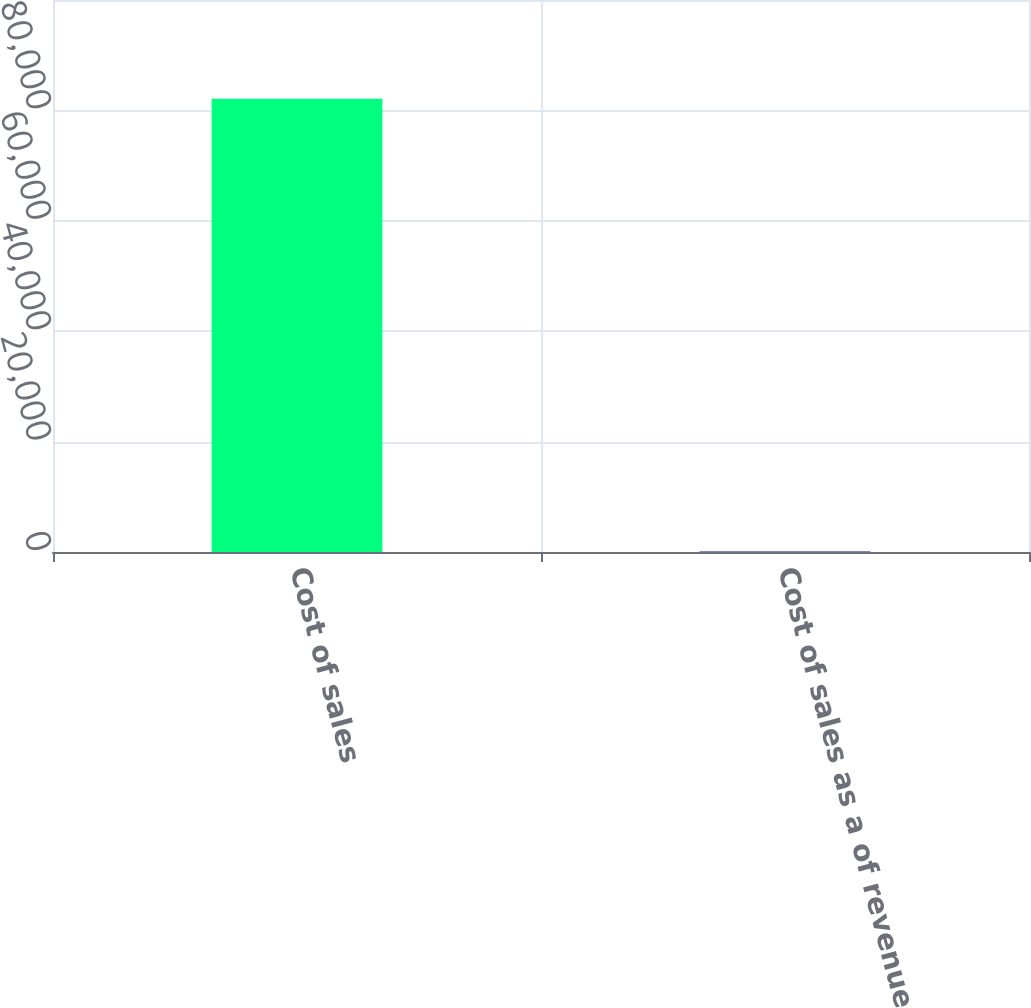Convert chart to OTSL. <chart><loc_0><loc_0><loc_500><loc_500><bar_chart><fcel>Cost of sales<fcel>Cost of sales as a of revenues<nl><fcel>82088<fcel>85.4<nl></chart> 